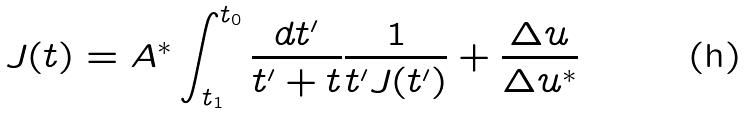<formula> <loc_0><loc_0><loc_500><loc_500>J ( t ) = A ^ { * } \int _ { t _ { 1 } } ^ { t _ { 0 } } \frac { d t ^ { \prime } } { t ^ { \prime } + t } \frac { 1 } { t ^ { \prime } J ( t ^ { \prime } ) } + \frac { \Delta u } { \Delta u ^ { * } }</formula> 